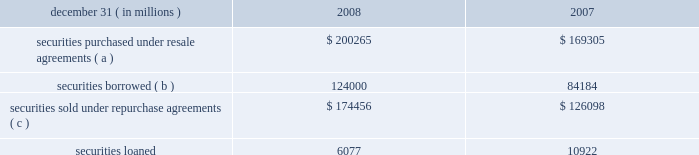Jpmorgan chase & co .
/ 2008 annual report 175jpmorgan chase & co .
/ 2008 annual report 175jpmorgan chase & co .
/ 2008 annual report 175jpmorgan chase & co .
/ 2008 annual report 175jpmorgan chase & co .
/ 2008 annual report 175 securities borrowed and securities lent are recorded at the amount of cash collateral advanced or received .
Securities borrowed consist primarily of government and equity securities .
Jpmorgan chase moni- tors the market value of the securities borrowed and lent on a daily basis and calls for additional collateral when appropriate .
Fees received or paid in connection with securities borrowed and lent are recorded in interest income or interest expense .
The table details the components of collateralized financings. .
( a ) includes resale agreements of $ 20.8 billion and $ 19.1 billion accounted for at fair value at december 31 , 2008 and 2007 , respectively .
( b ) includes securities borrowed of $ 3.4 billion accounted for at fair value at december 31 , 2008 .
( c ) includes repurchase agreements of $ 3.0 billion and $ 5.8 billion accounted for at fair value at december 31 , 2008 and 2007 , respectively .
Jpmorgan chase pledges certain financial instruments it owns to col- lateralize repurchase agreements and other securities financings .
Pledged securities that can be sold or repledged by the secured party are identified as financial instruments owned ( pledged to various parties ) on the consolidated balance sheets .
At december 31 , 2008 , the firm received securities as collateral that could be repledged , delivered or otherwise used with a fair value of approximately $ 511.9 billion .
This collateral was generally obtained under resale or securities borrowing agreements .
Of these securities , approximately $ 456.6 billion were repledged , delivered or otherwise used , generally as collateral under repurchase agreements , securities lending agreements or to cover short sales .
Note 14 2013 loans the accounting for a loan may differ based upon whether it is origi- nated or purchased and as to whether the loan is used in an invest- ing or trading strategy .
For purchased loans held-for-investment , the accounting also differs depending on whether a loan is credit- impaired at the date of acquisition .
Purchased loans with evidence of credit deterioration since the origination date and for which it is probable , at acquisition , that all contractually required payments receivable will not be collected are considered to be credit-impaired .
The measurement framework for loans in the consolidated financial statements is one of the following : 2022 at the principal amount outstanding , net of the allowance for loan losses , unearned income and any net deferred loan fees or costs , for loans held for investment ( other than purchased credit- impaired loans ) ; 2022 at the lower of cost or fair value , with valuation changes record- ed in noninterest revenue , for loans that are classified as held- for-sale ; or 2022 at fair value , with changes in fair value recorded in noninterest revenue , for loans classified as trading assets or risk managed on a fair value basis ; 2022 purchased credit-impaired loans held for investment are account- ed for under sop 03-3 and initially measured at fair value , which includes estimated future credit losses .
Accordingly , an allowance for loan losses related to these loans is not recorded at the acquisition date .
See note 5 on pages 156 2013158 of this annual report for further information on the firm 2019s elections of fair value accounting under sfas 159 .
See note 6 on pages 158 2013160 of this annual report for further information on loans carried at fair value and classified as trading assets .
For loans held for investment , other than purchased credit-impaired loans , interest income is recognized using the interest method or on a basis approximating a level rate of return over the term of the loan .
Loans within the held-for-investment portfolio that management decides to sell are transferred to the held-for-sale portfolio .
Transfers to held-for-sale are recorded at the lower of cost or fair value on the date of transfer .
Credit-related losses are charged off to the allowance for loan losses and losses due to changes in interest rates , or exchange rates , are recognized in noninterest revenue .
Loans within the held-for-sale portfolio that management decides to retain are transferred to the held-for-investment portfolio at the lower of cost or fair value .
These loans are subsequently assessed for impairment based on the firm 2019s allowance methodology .
For a fur- ther discussion of the methodologies used in establishing the firm 2019s allowance for loan losses , see note 15 on pages 178 2013180 of this annual report .
Nonaccrual loans are those on which the accrual of interest is dis- continued .
Loans ( other than certain consumer and purchased credit- impaired loans discussed below ) are placed on nonaccrual status immediately if , in the opinion of management , full payment of princi- pal or interest is in doubt , or when principal or interest is 90 days or more past due and collateral , if any , is insufficient to cover principal and interest .
Loans are charged off to the allowance for loan losses when it is highly certain that a loss has been realized .
Interest accrued but not collected at the date a loan is placed on nonaccrual status is reversed against interest income .
In addition , the amortiza- tion of net deferred loan fees is suspended .
Interest income on nonaccrual loans is recognized only to the extent it is received in cash .
However , where there is doubt regarding the ultimate col- lectibility of loan principal , all cash thereafter received is applied to reduce the carrying value of such loans ( i.e. , the cost recovery method ) .
Loans are restored to accrual status only when future pay- ments of interest and principal are reasonably assured .
Consumer loans , other than purchased credit-impaired loans , are generally charged to the allowance for loan losses upon reaching specified stages of delinquency , in accordance with the federal financial institutions examination council policy .
For example , credit card loans are charged off by the end of the month in which the account becomes 180 days past due or within 60 days from receiv- ing notification of the filing of bankruptcy , whichever is earlier .
Residential mortgage products are generally charged off to net real- izable value at no later than 180 days past due .
Other consumer .
What was the ratio of the securities borrowed to the securities loaned in 2008? 
Computations: (124000 / 6077)
Answer: 20.40481. Jpmorgan chase & co .
/ 2008 annual report 175jpmorgan chase & co .
/ 2008 annual report 175jpmorgan chase & co .
/ 2008 annual report 175jpmorgan chase & co .
/ 2008 annual report 175jpmorgan chase & co .
/ 2008 annual report 175 securities borrowed and securities lent are recorded at the amount of cash collateral advanced or received .
Securities borrowed consist primarily of government and equity securities .
Jpmorgan chase moni- tors the market value of the securities borrowed and lent on a daily basis and calls for additional collateral when appropriate .
Fees received or paid in connection with securities borrowed and lent are recorded in interest income or interest expense .
The table details the components of collateralized financings. .
( a ) includes resale agreements of $ 20.8 billion and $ 19.1 billion accounted for at fair value at december 31 , 2008 and 2007 , respectively .
( b ) includes securities borrowed of $ 3.4 billion accounted for at fair value at december 31 , 2008 .
( c ) includes repurchase agreements of $ 3.0 billion and $ 5.8 billion accounted for at fair value at december 31 , 2008 and 2007 , respectively .
Jpmorgan chase pledges certain financial instruments it owns to col- lateralize repurchase agreements and other securities financings .
Pledged securities that can be sold or repledged by the secured party are identified as financial instruments owned ( pledged to various parties ) on the consolidated balance sheets .
At december 31 , 2008 , the firm received securities as collateral that could be repledged , delivered or otherwise used with a fair value of approximately $ 511.9 billion .
This collateral was generally obtained under resale or securities borrowing agreements .
Of these securities , approximately $ 456.6 billion were repledged , delivered or otherwise used , generally as collateral under repurchase agreements , securities lending agreements or to cover short sales .
Note 14 2013 loans the accounting for a loan may differ based upon whether it is origi- nated or purchased and as to whether the loan is used in an invest- ing or trading strategy .
For purchased loans held-for-investment , the accounting also differs depending on whether a loan is credit- impaired at the date of acquisition .
Purchased loans with evidence of credit deterioration since the origination date and for which it is probable , at acquisition , that all contractually required payments receivable will not be collected are considered to be credit-impaired .
The measurement framework for loans in the consolidated financial statements is one of the following : 2022 at the principal amount outstanding , net of the allowance for loan losses , unearned income and any net deferred loan fees or costs , for loans held for investment ( other than purchased credit- impaired loans ) ; 2022 at the lower of cost or fair value , with valuation changes record- ed in noninterest revenue , for loans that are classified as held- for-sale ; or 2022 at fair value , with changes in fair value recorded in noninterest revenue , for loans classified as trading assets or risk managed on a fair value basis ; 2022 purchased credit-impaired loans held for investment are account- ed for under sop 03-3 and initially measured at fair value , which includes estimated future credit losses .
Accordingly , an allowance for loan losses related to these loans is not recorded at the acquisition date .
See note 5 on pages 156 2013158 of this annual report for further information on the firm 2019s elections of fair value accounting under sfas 159 .
See note 6 on pages 158 2013160 of this annual report for further information on loans carried at fair value and classified as trading assets .
For loans held for investment , other than purchased credit-impaired loans , interest income is recognized using the interest method or on a basis approximating a level rate of return over the term of the loan .
Loans within the held-for-investment portfolio that management decides to sell are transferred to the held-for-sale portfolio .
Transfers to held-for-sale are recorded at the lower of cost or fair value on the date of transfer .
Credit-related losses are charged off to the allowance for loan losses and losses due to changes in interest rates , or exchange rates , are recognized in noninterest revenue .
Loans within the held-for-sale portfolio that management decides to retain are transferred to the held-for-investment portfolio at the lower of cost or fair value .
These loans are subsequently assessed for impairment based on the firm 2019s allowance methodology .
For a fur- ther discussion of the methodologies used in establishing the firm 2019s allowance for loan losses , see note 15 on pages 178 2013180 of this annual report .
Nonaccrual loans are those on which the accrual of interest is dis- continued .
Loans ( other than certain consumer and purchased credit- impaired loans discussed below ) are placed on nonaccrual status immediately if , in the opinion of management , full payment of princi- pal or interest is in doubt , or when principal or interest is 90 days or more past due and collateral , if any , is insufficient to cover principal and interest .
Loans are charged off to the allowance for loan losses when it is highly certain that a loss has been realized .
Interest accrued but not collected at the date a loan is placed on nonaccrual status is reversed against interest income .
In addition , the amortiza- tion of net deferred loan fees is suspended .
Interest income on nonaccrual loans is recognized only to the extent it is received in cash .
However , where there is doubt regarding the ultimate col- lectibility of loan principal , all cash thereafter received is applied to reduce the carrying value of such loans ( i.e. , the cost recovery method ) .
Loans are restored to accrual status only when future pay- ments of interest and principal are reasonably assured .
Consumer loans , other than purchased credit-impaired loans , are generally charged to the allowance for loan losses upon reaching specified stages of delinquency , in accordance with the federal financial institutions examination council policy .
For example , credit card loans are charged off by the end of the month in which the account becomes 180 days past due or within 60 days from receiv- ing notification of the filing of bankruptcy , whichever is earlier .
Residential mortgage products are generally charged off to net real- izable value at no later than 180 days past due .
Other consumer .
How much of the securities borrowed in 2008 were fair value resale agreements? 
Computations: ((20.8 * 1000) / 124000)
Answer: 0.16774. Jpmorgan chase & co .
/ 2008 annual report 175jpmorgan chase & co .
/ 2008 annual report 175jpmorgan chase & co .
/ 2008 annual report 175jpmorgan chase & co .
/ 2008 annual report 175jpmorgan chase & co .
/ 2008 annual report 175 securities borrowed and securities lent are recorded at the amount of cash collateral advanced or received .
Securities borrowed consist primarily of government and equity securities .
Jpmorgan chase moni- tors the market value of the securities borrowed and lent on a daily basis and calls for additional collateral when appropriate .
Fees received or paid in connection with securities borrowed and lent are recorded in interest income or interest expense .
The table details the components of collateralized financings. .
( a ) includes resale agreements of $ 20.8 billion and $ 19.1 billion accounted for at fair value at december 31 , 2008 and 2007 , respectively .
( b ) includes securities borrowed of $ 3.4 billion accounted for at fair value at december 31 , 2008 .
( c ) includes repurchase agreements of $ 3.0 billion and $ 5.8 billion accounted for at fair value at december 31 , 2008 and 2007 , respectively .
Jpmorgan chase pledges certain financial instruments it owns to col- lateralize repurchase agreements and other securities financings .
Pledged securities that can be sold or repledged by the secured party are identified as financial instruments owned ( pledged to various parties ) on the consolidated balance sheets .
At december 31 , 2008 , the firm received securities as collateral that could be repledged , delivered or otherwise used with a fair value of approximately $ 511.9 billion .
This collateral was generally obtained under resale or securities borrowing agreements .
Of these securities , approximately $ 456.6 billion were repledged , delivered or otherwise used , generally as collateral under repurchase agreements , securities lending agreements or to cover short sales .
Note 14 2013 loans the accounting for a loan may differ based upon whether it is origi- nated or purchased and as to whether the loan is used in an invest- ing or trading strategy .
For purchased loans held-for-investment , the accounting also differs depending on whether a loan is credit- impaired at the date of acquisition .
Purchased loans with evidence of credit deterioration since the origination date and for which it is probable , at acquisition , that all contractually required payments receivable will not be collected are considered to be credit-impaired .
The measurement framework for loans in the consolidated financial statements is one of the following : 2022 at the principal amount outstanding , net of the allowance for loan losses , unearned income and any net deferred loan fees or costs , for loans held for investment ( other than purchased credit- impaired loans ) ; 2022 at the lower of cost or fair value , with valuation changes record- ed in noninterest revenue , for loans that are classified as held- for-sale ; or 2022 at fair value , with changes in fair value recorded in noninterest revenue , for loans classified as trading assets or risk managed on a fair value basis ; 2022 purchased credit-impaired loans held for investment are account- ed for under sop 03-3 and initially measured at fair value , which includes estimated future credit losses .
Accordingly , an allowance for loan losses related to these loans is not recorded at the acquisition date .
See note 5 on pages 156 2013158 of this annual report for further information on the firm 2019s elections of fair value accounting under sfas 159 .
See note 6 on pages 158 2013160 of this annual report for further information on loans carried at fair value and classified as trading assets .
For loans held for investment , other than purchased credit-impaired loans , interest income is recognized using the interest method or on a basis approximating a level rate of return over the term of the loan .
Loans within the held-for-investment portfolio that management decides to sell are transferred to the held-for-sale portfolio .
Transfers to held-for-sale are recorded at the lower of cost or fair value on the date of transfer .
Credit-related losses are charged off to the allowance for loan losses and losses due to changes in interest rates , or exchange rates , are recognized in noninterest revenue .
Loans within the held-for-sale portfolio that management decides to retain are transferred to the held-for-investment portfolio at the lower of cost or fair value .
These loans are subsequently assessed for impairment based on the firm 2019s allowance methodology .
For a fur- ther discussion of the methodologies used in establishing the firm 2019s allowance for loan losses , see note 15 on pages 178 2013180 of this annual report .
Nonaccrual loans are those on which the accrual of interest is dis- continued .
Loans ( other than certain consumer and purchased credit- impaired loans discussed below ) are placed on nonaccrual status immediately if , in the opinion of management , full payment of princi- pal or interest is in doubt , or when principal or interest is 90 days or more past due and collateral , if any , is insufficient to cover principal and interest .
Loans are charged off to the allowance for loan losses when it is highly certain that a loss has been realized .
Interest accrued but not collected at the date a loan is placed on nonaccrual status is reversed against interest income .
In addition , the amortiza- tion of net deferred loan fees is suspended .
Interest income on nonaccrual loans is recognized only to the extent it is received in cash .
However , where there is doubt regarding the ultimate col- lectibility of loan principal , all cash thereafter received is applied to reduce the carrying value of such loans ( i.e. , the cost recovery method ) .
Loans are restored to accrual status only when future pay- ments of interest and principal are reasonably assured .
Consumer loans , other than purchased credit-impaired loans , are generally charged to the allowance for loan losses upon reaching specified stages of delinquency , in accordance with the federal financial institutions examination council policy .
For example , credit card loans are charged off by the end of the month in which the account becomes 180 days past due or within 60 days from receiv- ing notification of the filing of bankruptcy , whichever is earlier .
Residential mortgage products are generally charged off to net real- izable value at no later than 180 days past due .
Other consumer .
What was the ratio of the securities purchased under resale agreements to the of the resale agreements accounted for at fair value? 
Computations: (200265 / 20.8)
Answer: 9628.125. 